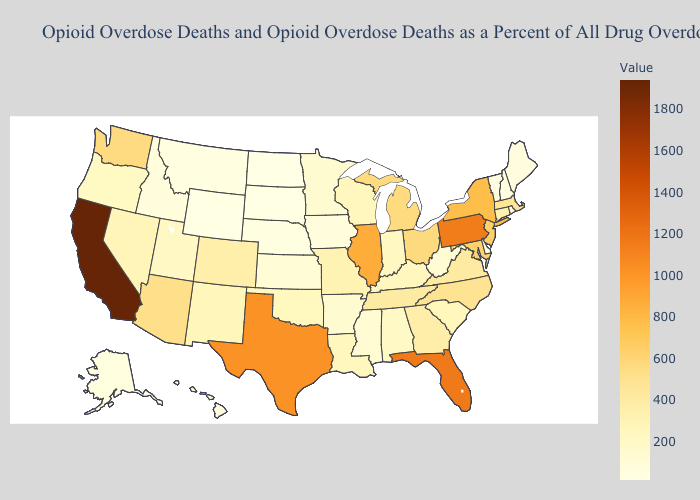Does Montana have the highest value in the USA?
Be succinct. No. Which states have the lowest value in the Northeast?
Be succinct. Vermont. Among the states that border Massachusetts , which have the highest value?
Write a very short answer. New York. Among the states that border Iowa , which have the lowest value?
Keep it brief. South Dakota. Among the states that border Massachusetts , which have the lowest value?
Short answer required. Vermont. Which states have the highest value in the USA?
Short answer required. California. 